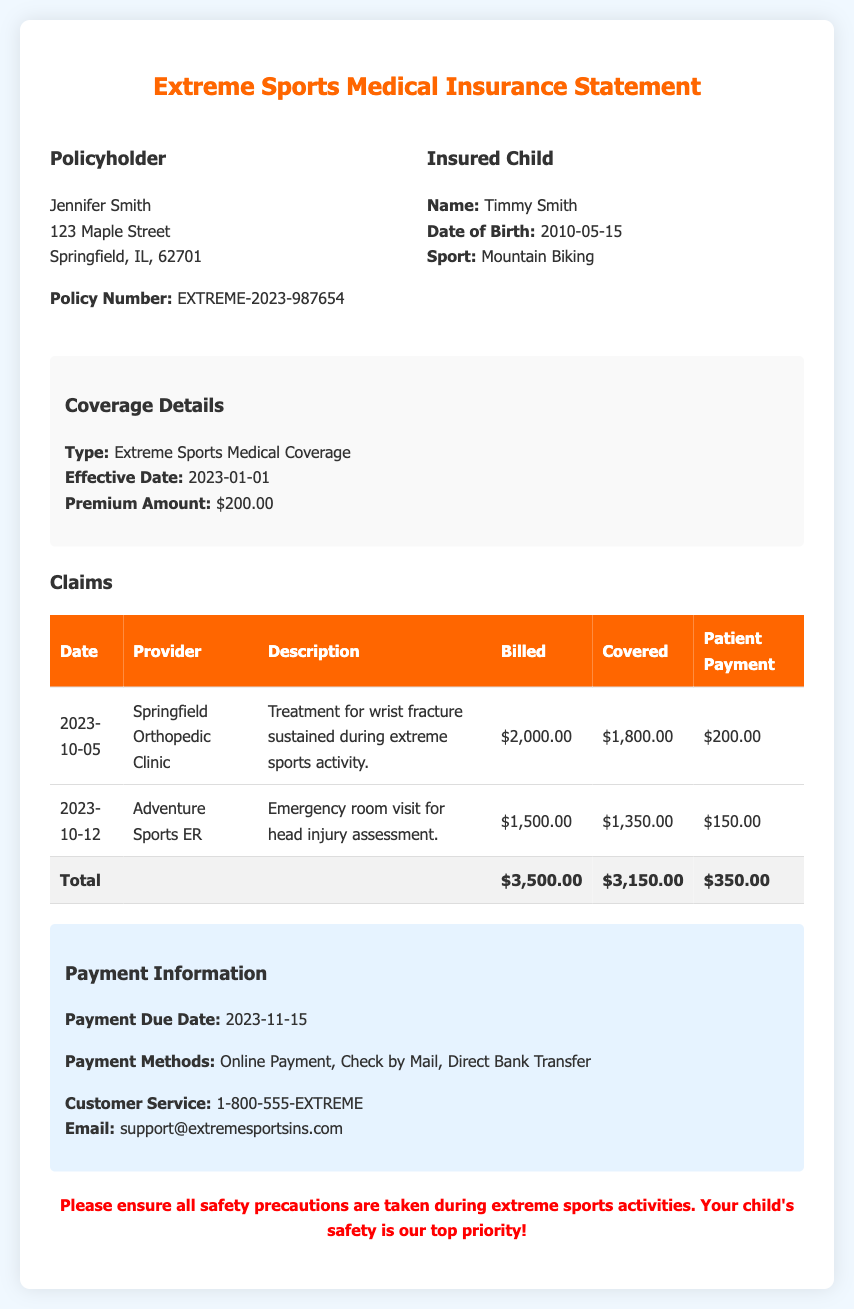What is the name of the policyholder? The name of the policyholder is listed in the document, which is Jennifer Smith.
Answer: Jennifer Smith What is the sport that Timmy participates in? The document specifies the type of sport covered under the insurance, which is Mountain Biking.
Answer: Mountain Biking What was the date of the emergency room visit? The claims table indicates the date of the emergency room visit for a head injury assessment, which is 2023-10-12.
Answer: 2023-10-12 What is the total billed amount for all claims? The total billed amount is calculated by summing the billed amounts from the claims, which is $3,500.00.
Answer: $3,500.00 How much did Timmy's coverage pay for the wrist fracture treatment? The covered amount for the wrist fracture treatment is specifically listed in the claims table, which is $1,800.00.
Answer: $1,800.00 What is the payment due date? The document states that the payment due date for this month's bill is 2023-11-15.
Answer: 2023-11-15 How much was the patient payment for the emergency room visit? The patient payment for the emergency room visit is detailed in the claims, which is $150.00.
Answer: $150.00 What is the insurance policy number? The policy number is explicitly provided in the document, which is EXTREME-2023-987654.
Answer: EXTREME-2023-987654 What are the payment methods available? The document lists the payment methods, which include Online Payment, Check by Mail, and Direct Bank Transfer.
Answer: Online Payment, Check by Mail, Direct Bank Transfer 